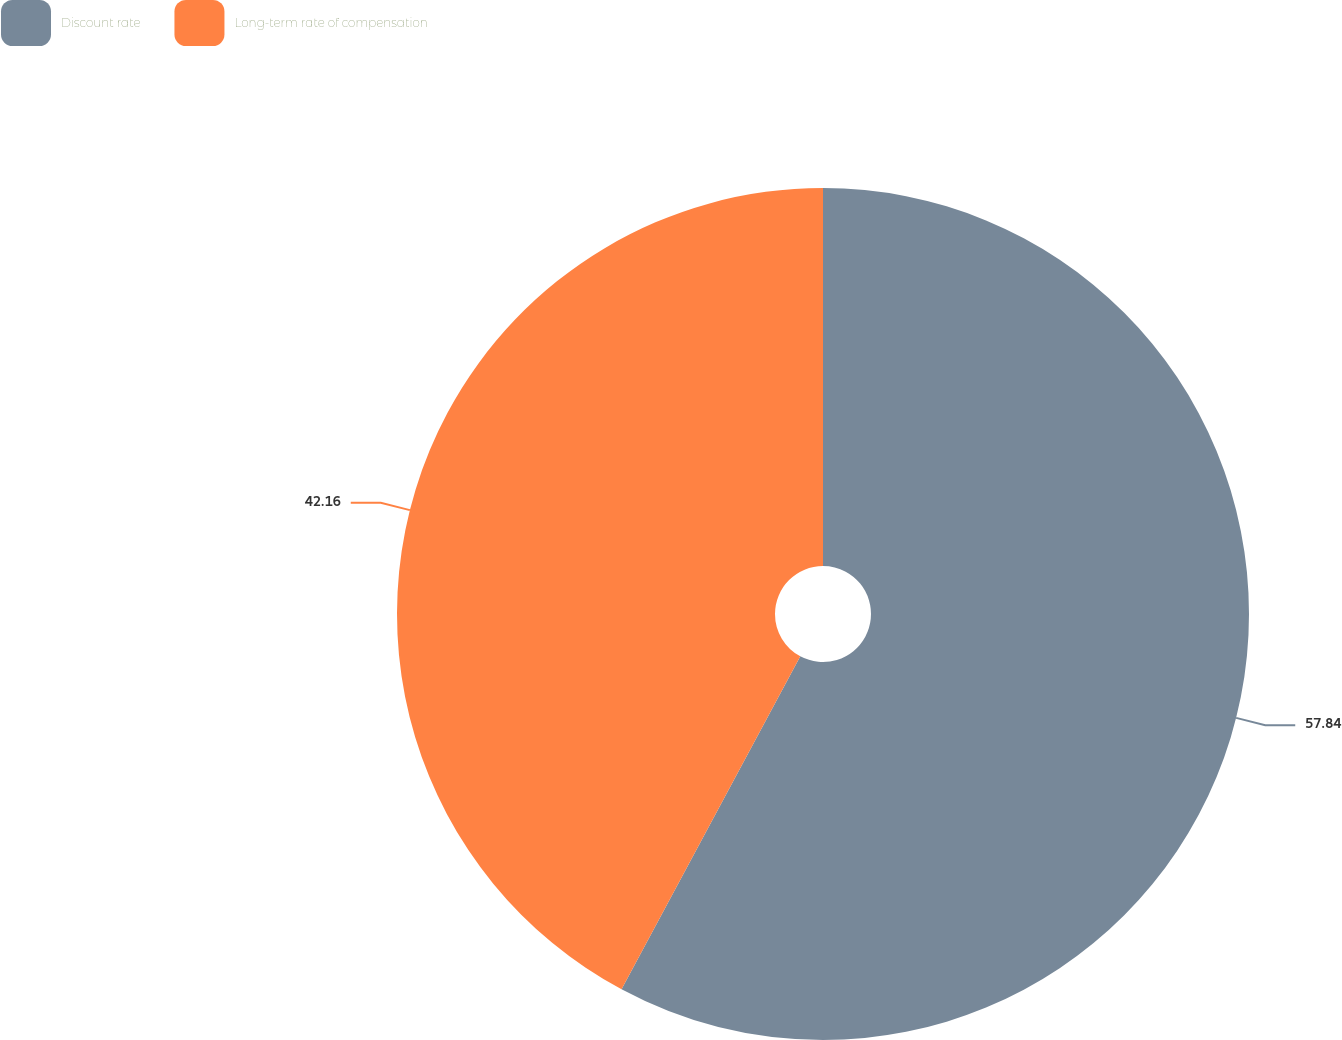Convert chart. <chart><loc_0><loc_0><loc_500><loc_500><pie_chart><fcel>Discount rate<fcel>Long-term rate of compensation<nl><fcel>57.84%<fcel>42.16%<nl></chart> 